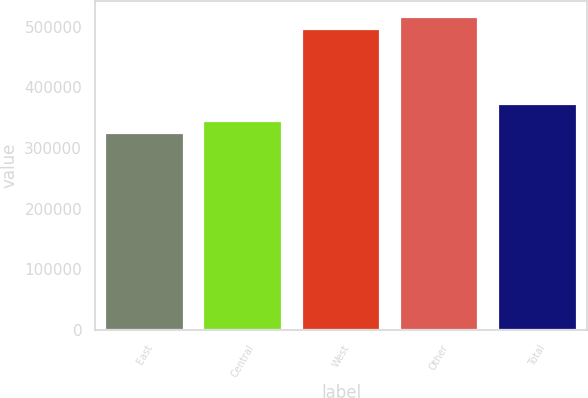Convert chart to OTSL. <chart><loc_0><loc_0><loc_500><loc_500><bar_chart><fcel>East<fcel>Central<fcel>West<fcel>Other<fcel>Total<nl><fcel>325000<fcel>344200<fcel>496000<fcel>517000<fcel>373000<nl></chart> 